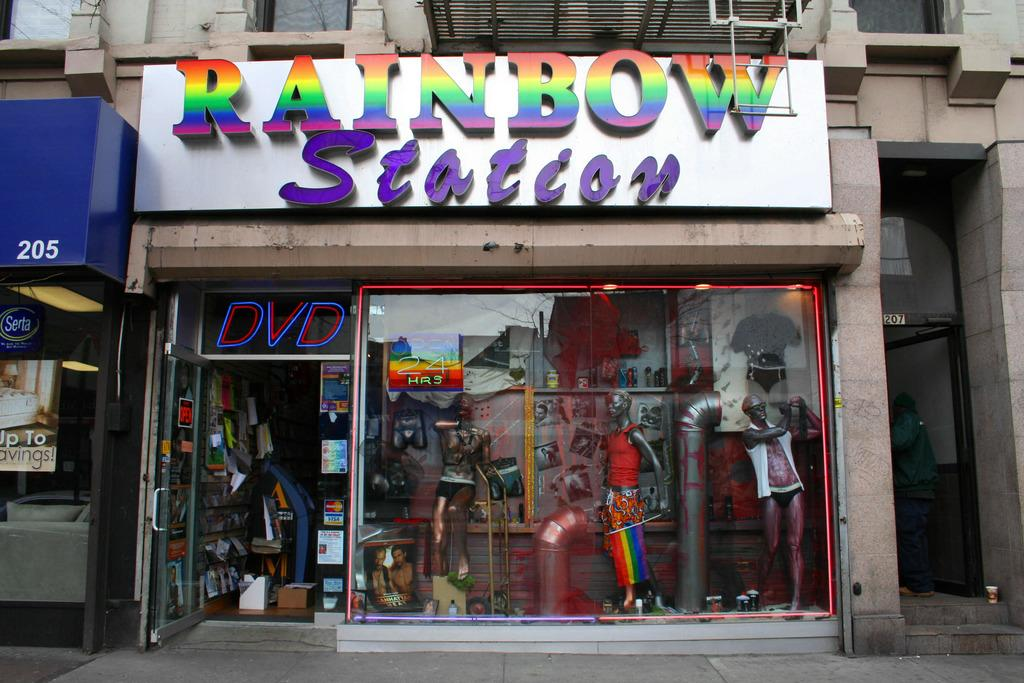<image>
Offer a succinct explanation of the picture presented. A store with the words Rainbow Station above the entrance in rainbow colors. 